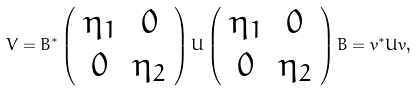<formula> <loc_0><loc_0><loc_500><loc_500>V = B ^ { * } \left ( \begin{array} { c c } \eta _ { 1 } & 0 \\ 0 & \eta _ { 2 } \end{array} \right ) U \left ( \begin{array} { c c } \eta _ { 1 } & 0 \\ 0 & \eta _ { 2 } \end{array} \right ) B = v ^ { * } U v ,</formula> 